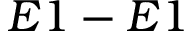Convert formula to latex. <formula><loc_0><loc_0><loc_500><loc_500>E 1 - E 1</formula> 